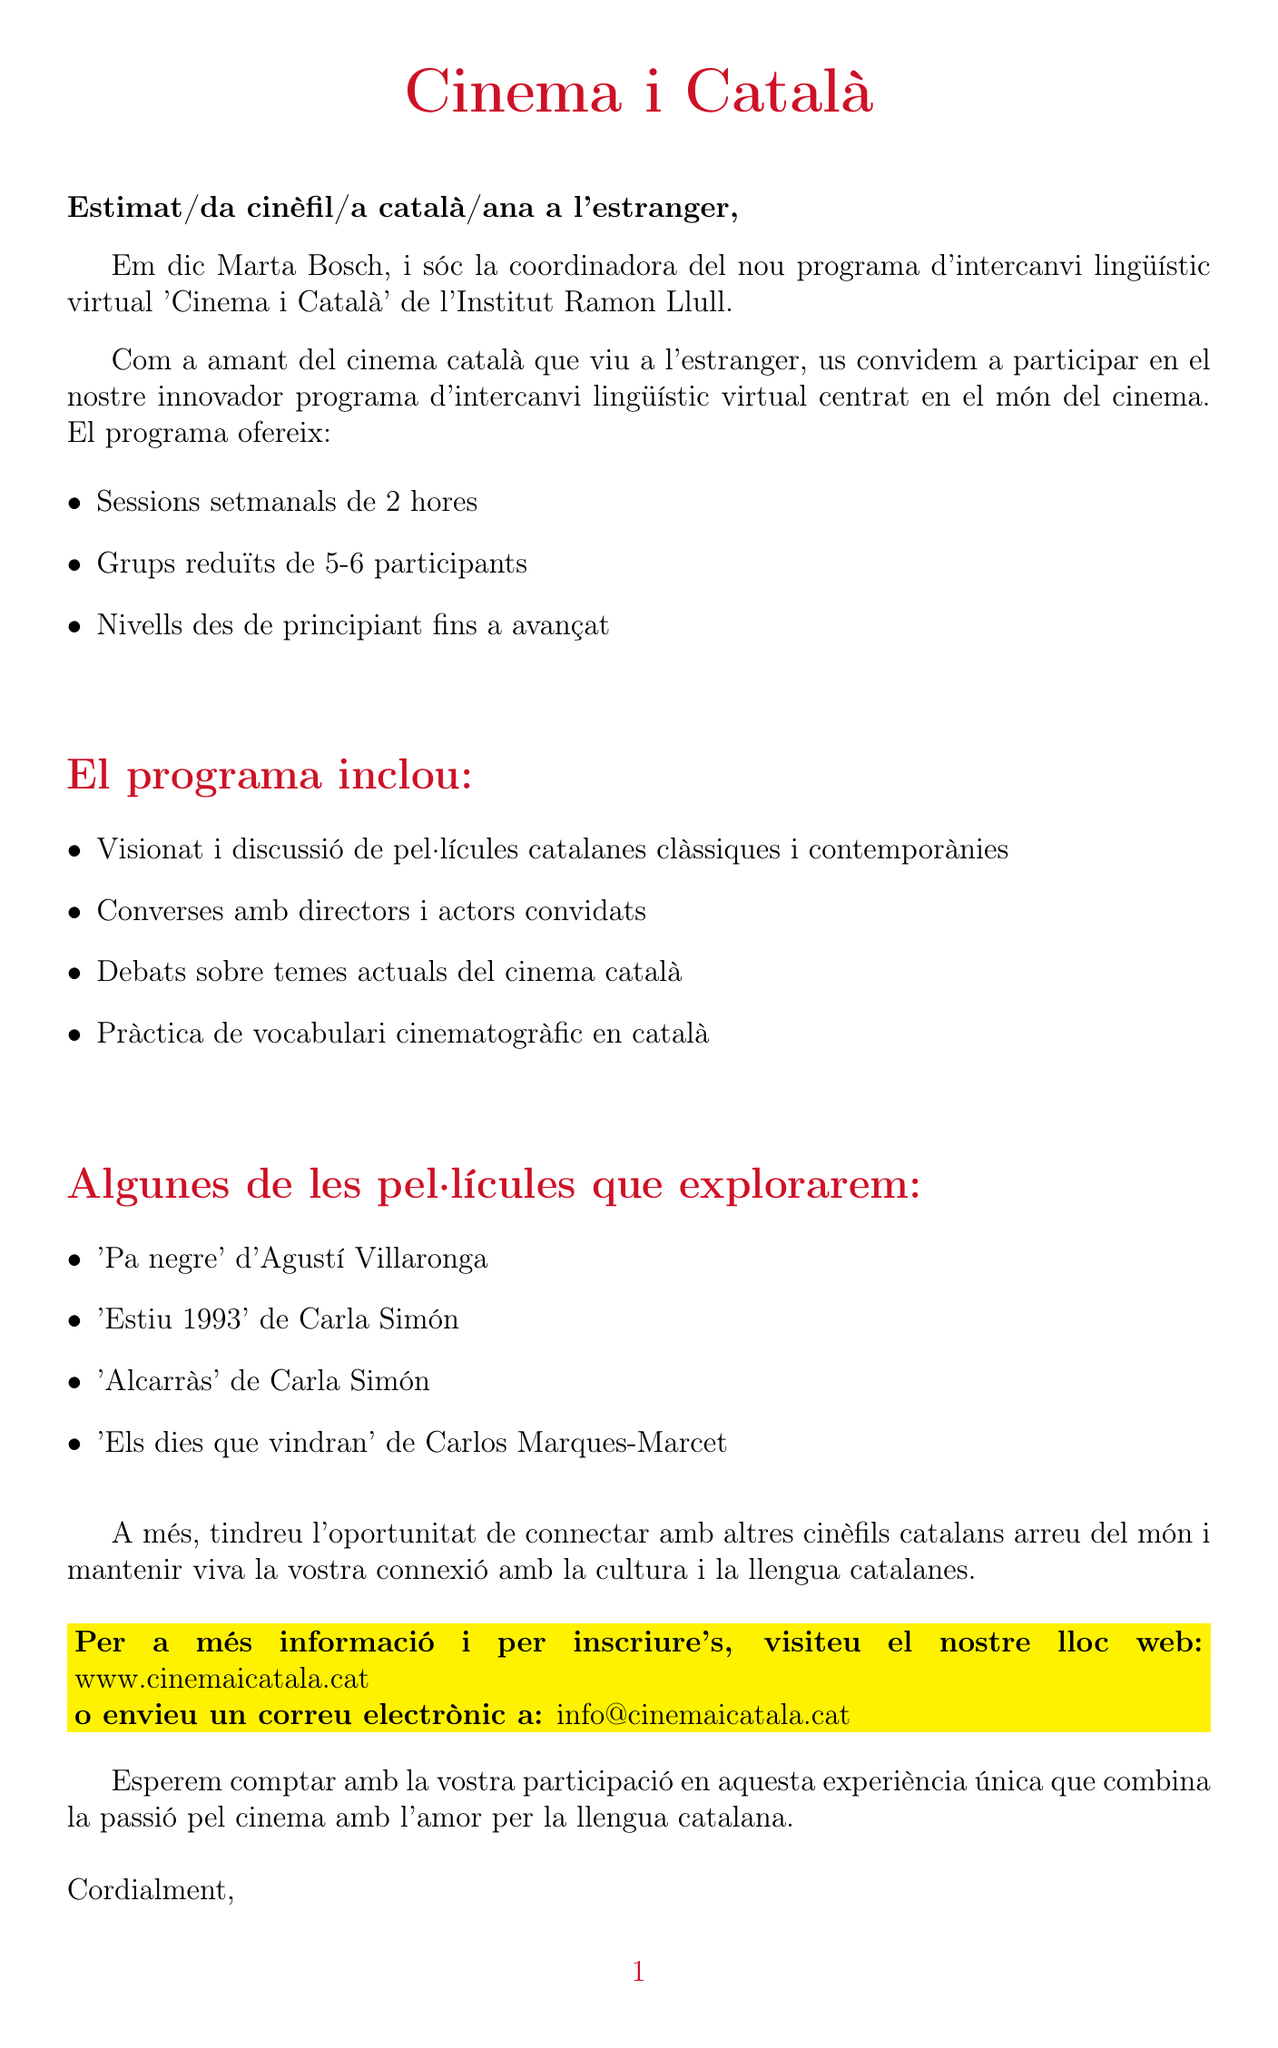What is the duration of the program? The document states that the program lasts for 3 months and consists of 12 sessions.
Answer: 3 mesos (12 sessions) Who is the coordinator of the program? The letter mentions that Marta Bosch is the coordinator of the 'Cinema i Català' program.
Answer: Marta Bosch When does the program start? According to the letter, the program's start date is mentioned.
Answer: 15 de setembre de 2023 What is the cost of the complete program? The document specifies the total cost for participation in the program.
Answer: 150€ per al programa complet How many participants are in each group? The letter indicates the maximum number of participants per group for the language exchange sessions.
Answer: 5-6 participants What types of films will be explored? The document lists several films that will be part of the program's exploration.
Answer: 'Pa negre', 'Estiu 1993', 'Alcarràs', 'Els dies que vindran' What is the main focus of the program? The letter highlights the primary theme of the virtual language exchange program.
Answer: Món del cinema What technical requirements are specified? The document provides a list of technical requirements necessary for participation in the program.
Answer: Connexió a internet estable, Càmera web i micròfon, Compte de Zoom What kind of activities will participants engage in? The document outlines various activities included in the program.
Answer: Visionat i discussió de pel·lícules, Converses amb directors i actors, Debats sobre temes actuals, Pràctica de vocabulari 